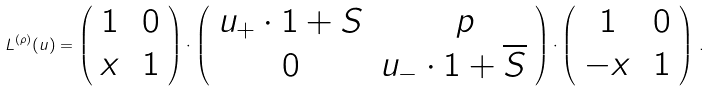Convert formula to latex. <formula><loc_0><loc_0><loc_500><loc_500>L ^ { ( \rho ) } ( u ) = \left ( \begin{array} { c c } 1 & \, 0 \\ x & \, 1 \end{array} \right ) \cdot \left ( \begin{array} { c c } u _ { + } \cdot 1 + S & \ \ p \\ 0 & u _ { - } \cdot 1 + \overline { S } \end{array} \right ) \cdot \left ( \begin{array} { c c } 1 & \, 0 \\ - x & \, 1 \end{array} \right ) \, .</formula> 